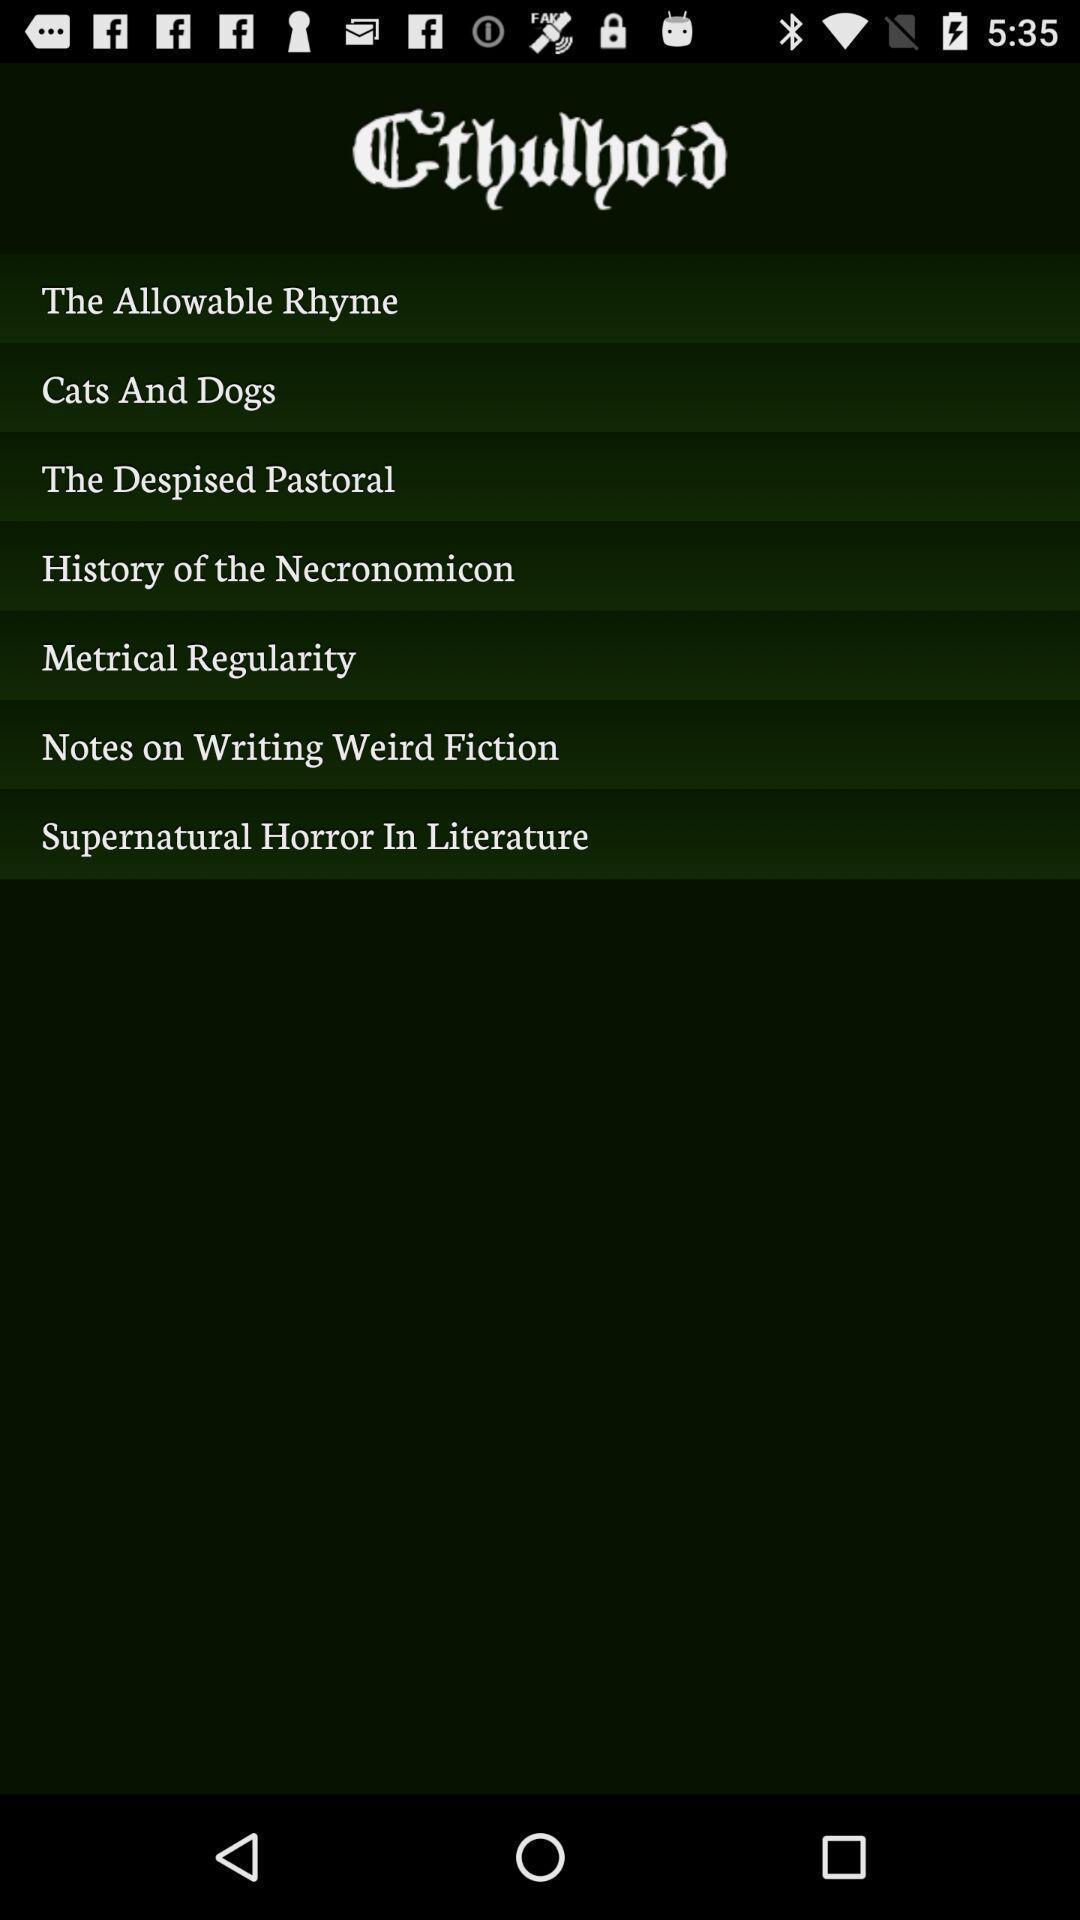Describe the content in this image. Screen displaying list of topics. 